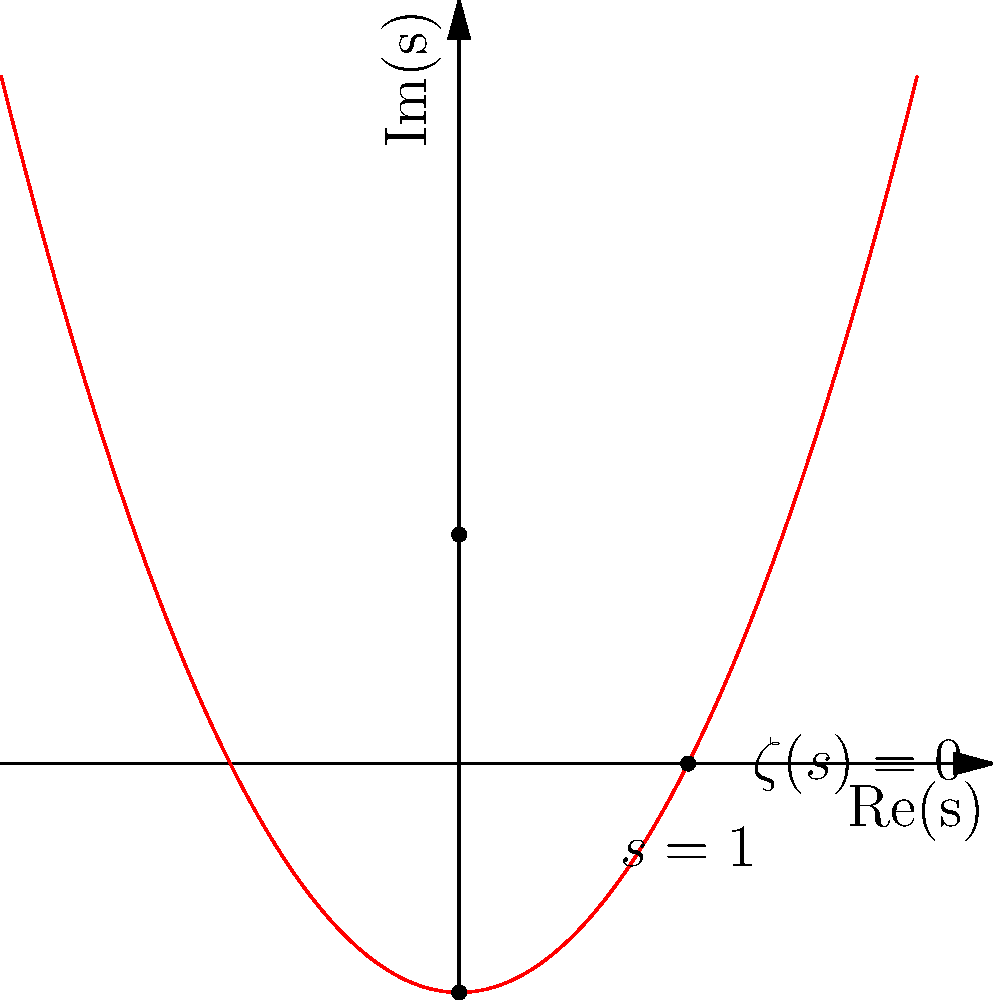In the complex plane plot of the Riemann zeta function $\zeta(s)$, what do the blue and red curves represent, and what is the significance of the labeled point at $s=1$? To understand this plot of the Riemann zeta function $\zeta(s)$, let's break it down step-by-step:

1. The blue curve represents the set of points where $\text{Re}(\zeta(s)) = 0$. This means that for any point on this curve, the real part of $\zeta(s)$ is zero.

2. The red curve represents the set of points where $\text{Im}(\zeta(s)) = 0$. This means that for any point on this curve, the imaginary part of $\zeta(s)$ is zero.

3. The intersections of these curves (excluding $s=1$) are the zeros of the Riemann zeta function. We can see two such points at $s = \frac{1}{2} \pm i$, which are known as the "trivial zeros" of the function.

4. The point labeled at $s=1$ is significant because it represents the pole of the Riemann zeta function. This is the only singularity of $\zeta(s)$ in the entire complex plane.

5. The Riemann zeta function has a simple pole at $s=1$ with residue 1. This means that as $s$ approaches 1, the value of $\zeta(s)$ grows without bound.

6. The behavior of $\zeta(s)$ near $s=1$ is crucial in number theory, particularly in the study of the distribution of prime numbers. It's related to the asymptotic behavior of the prime counting function.

7. The region to the right of the line $\text{Re}(s) = 1$ is where the Dirichlet series definition of $\zeta(s)$ converges absolutely.

The Riemann Hypothesis, one of the most famous unsolved problems in mathematics, states that all non-trivial zeros of $\zeta(s)$ have real part equal to $\frac{1}{2}$. This would correspond to all intersections of the blue and red curves (except $s=1$) lying on the vertical line $\text{Re}(s) = \frac{1}{2}$.
Answer: Blue: $\text{Re}(\zeta(s)) = 0$; Red: $\text{Im}(\zeta(s)) = 0$; $s=1$ is the pole of $\zeta(s)$. 